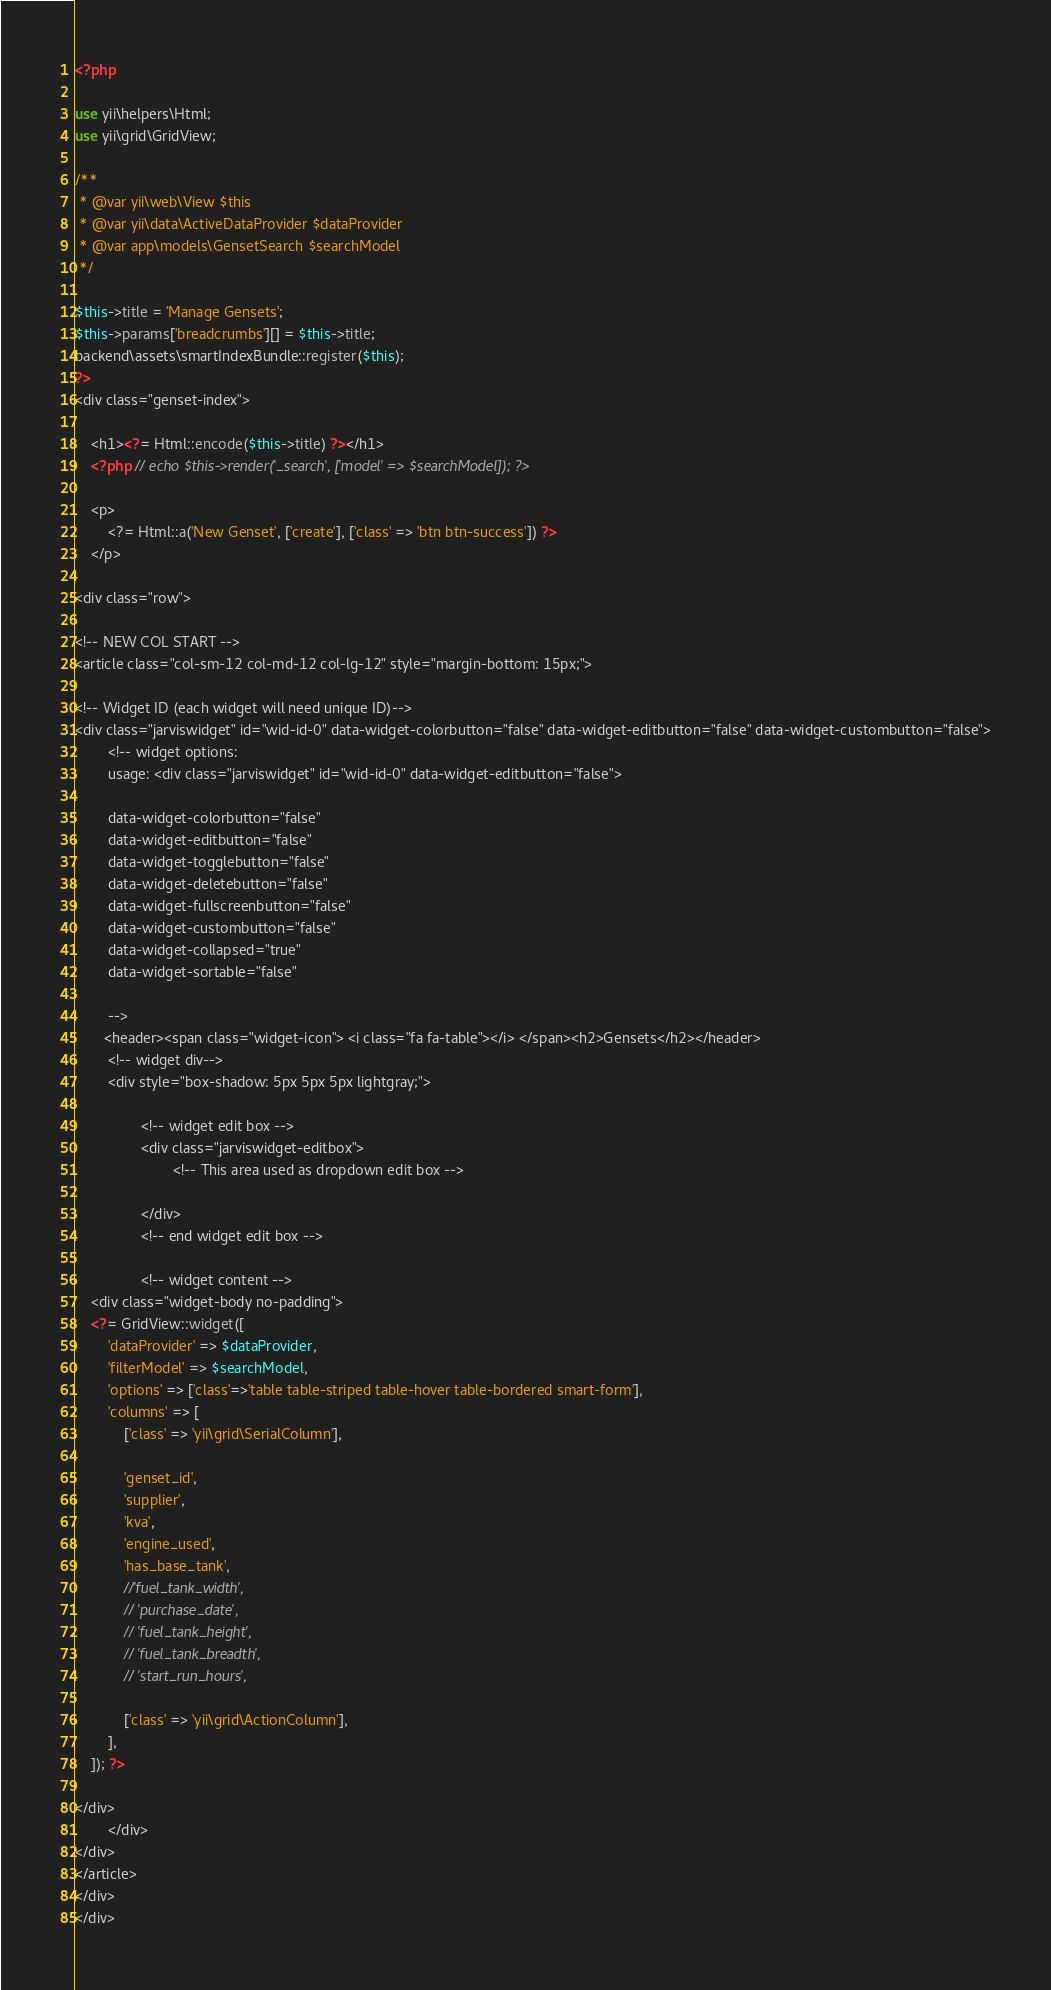<code> <loc_0><loc_0><loc_500><loc_500><_PHP_><?php

use yii\helpers\Html;
use yii\grid\GridView;

/**
 * @var yii\web\View $this
 * @var yii\data\ActiveDataProvider $dataProvider
 * @var app\models\GensetSearch $searchModel
 */

$this->title = 'Manage Gensets';
$this->params['breadcrumbs'][] = $this->title;
backend\assets\smartIndexBundle::register($this);
?>
<div class="genset-index">

    <h1><?= Html::encode($this->title) ?></h1>
    <?php // echo $this->render('_search', ['model' => $searchModel]); ?>

    <p>
        <?= Html::a('New Genset', ['create'], ['class' => 'btn btn-success']) ?>
    </p>

<div class="row">

<!-- NEW COL START -->
<article class="col-sm-12 col-md-12 col-lg-12" style="margin-bottom: 15px;">

<!-- Widget ID (each widget will need unique ID)-->
<div class="jarviswidget" id="wid-id-0" data-widget-colorbutton="false" data-widget-editbutton="false" data-widget-custombutton="false">
        <!-- widget options:
        usage: <div class="jarviswidget" id="wid-id-0" data-widget-editbutton="false">

        data-widget-colorbutton="false"
        data-widget-editbutton="false"
        data-widget-togglebutton="false"
        data-widget-deletebutton="false"
        data-widget-fullscreenbutton="false"
        data-widget-custombutton="false"
        data-widget-collapsed="true"
        data-widget-sortable="false"

        -->
       <header><span class="widget-icon"> <i class="fa fa-table"></i> </span><h2>Gensets</h2></header>
        <!-- widget div-->
        <div style="box-shadow: 5px 5px 5px lightgray;">

                <!-- widget edit box -->
                <div class="jarviswidget-editbox">
                        <!-- This area used as dropdown edit box -->

                </div>
                <!-- end widget edit box -->

                <!-- widget content -->
    <div class="widget-body no-padding">
    <?= GridView::widget([
        'dataProvider' => $dataProvider,
        'filterModel' => $searchModel,
        'options' => ['class'=>'table table-striped table-hover table-bordered smart-form'],
        'columns' => [
            ['class' => 'yii\grid\SerialColumn'],

            'genset_id',
            'supplier',
            'kva',
            'engine_used',
            'has_base_tank',
            //'fuel_tank_width',
            // 'purchase_date',
            // 'fuel_tank_height',
            // 'fuel_tank_breadth',
            // 'start_run_hours',

            ['class' => 'yii\grid\ActionColumn'],
        ],
    ]); ?>

</div>
        </div>
</div>
</article>
</div>
</div>
</code> 